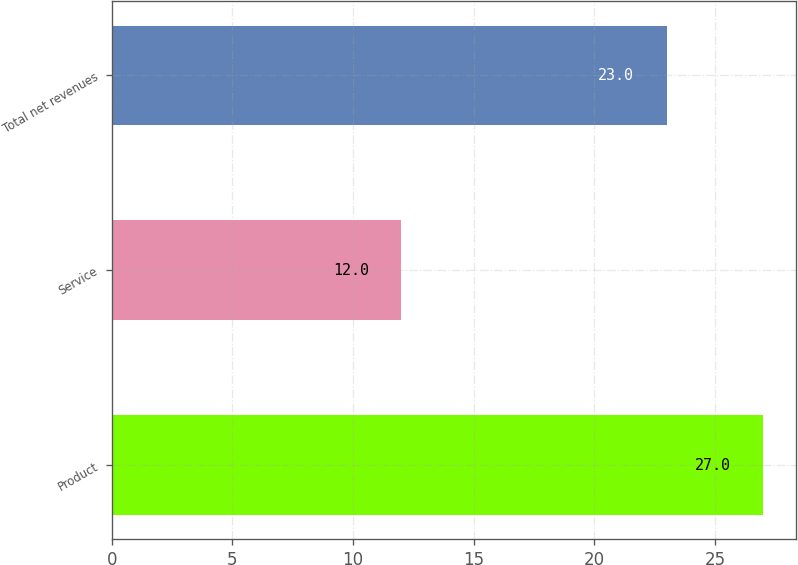Convert chart to OTSL. <chart><loc_0><loc_0><loc_500><loc_500><bar_chart><fcel>Product<fcel>Service<fcel>Total net revenues<nl><fcel>27<fcel>12<fcel>23<nl></chart> 